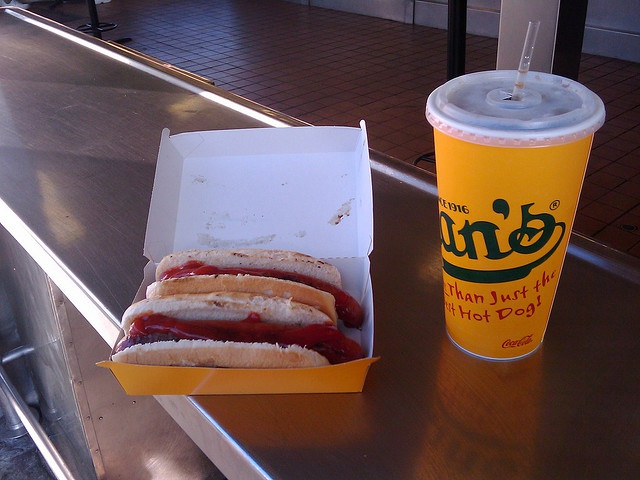Describe the objects in this image and their specific colors. I can see dining table in gray, black, and maroon tones, cup in gray, red, orange, darkgray, and black tones, hot dog in gray, maroon, darkgray, and black tones, sandwich in gray, maroon, darkgray, and black tones, and hot dog in gray, brown, darkgray, and maroon tones in this image. 